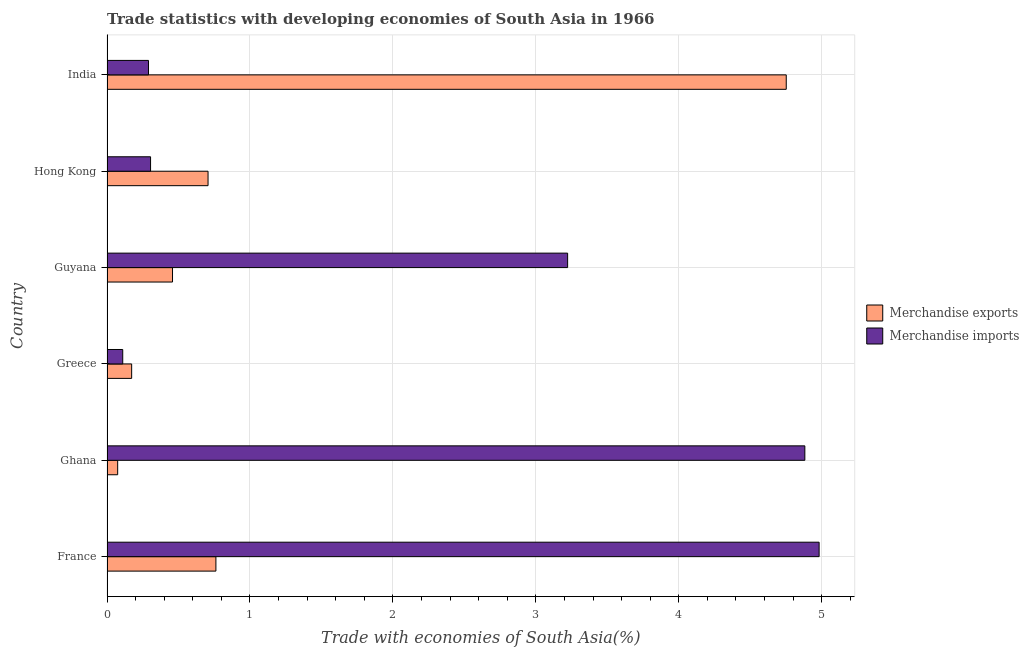Are the number of bars per tick equal to the number of legend labels?
Ensure brevity in your answer.  Yes. Are the number of bars on each tick of the Y-axis equal?
Keep it short and to the point. Yes. What is the label of the 1st group of bars from the top?
Your answer should be compact. India. What is the merchandise imports in Ghana?
Ensure brevity in your answer.  4.88. Across all countries, what is the maximum merchandise exports?
Offer a terse response. 4.75. Across all countries, what is the minimum merchandise imports?
Offer a terse response. 0.11. In which country was the merchandise imports maximum?
Offer a terse response. France. In which country was the merchandise exports minimum?
Keep it short and to the point. Ghana. What is the total merchandise exports in the graph?
Provide a short and direct response. 6.93. What is the difference between the merchandise imports in France and that in Hong Kong?
Your answer should be compact. 4.68. What is the difference between the merchandise imports in Hong Kong and the merchandise exports in Greece?
Your answer should be compact. 0.13. What is the average merchandise imports per country?
Provide a succinct answer. 2.3. What is the difference between the merchandise exports and merchandise imports in France?
Ensure brevity in your answer.  -4.22. In how many countries, is the merchandise exports greater than 4.6 %?
Keep it short and to the point. 1. What is the ratio of the merchandise exports in Guyana to that in Hong Kong?
Provide a short and direct response. 0.65. Is the merchandise imports in Guyana less than that in Hong Kong?
Your response must be concise. No. What is the difference between the highest and the second highest merchandise exports?
Ensure brevity in your answer.  3.99. What is the difference between the highest and the lowest merchandise exports?
Your answer should be very brief. 4.68. In how many countries, is the merchandise exports greater than the average merchandise exports taken over all countries?
Provide a succinct answer. 1. What does the 1st bar from the top in France represents?
Make the answer very short. Merchandise imports. What does the 1st bar from the bottom in Ghana represents?
Your answer should be very brief. Merchandise exports. How many bars are there?
Keep it short and to the point. 12. Are the values on the major ticks of X-axis written in scientific E-notation?
Provide a short and direct response. No. Does the graph contain grids?
Offer a terse response. Yes. Where does the legend appear in the graph?
Your answer should be compact. Center right. How are the legend labels stacked?
Ensure brevity in your answer.  Vertical. What is the title of the graph?
Your answer should be very brief. Trade statistics with developing economies of South Asia in 1966. What is the label or title of the X-axis?
Ensure brevity in your answer.  Trade with economies of South Asia(%). What is the Trade with economies of South Asia(%) in Merchandise exports in France?
Offer a terse response. 0.76. What is the Trade with economies of South Asia(%) of Merchandise imports in France?
Your answer should be compact. 4.98. What is the Trade with economies of South Asia(%) in Merchandise exports in Ghana?
Make the answer very short. 0.07. What is the Trade with economies of South Asia(%) of Merchandise imports in Ghana?
Offer a very short reply. 4.88. What is the Trade with economies of South Asia(%) of Merchandise exports in Greece?
Offer a terse response. 0.17. What is the Trade with economies of South Asia(%) in Merchandise imports in Greece?
Your answer should be very brief. 0.11. What is the Trade with economies of South Asia(%) of Merchandise exports in Guyana?
Offer a very short reply. 0.46. What is the Trade with economies of South Asia(%) in Merchandise imports in Guyana?
Your answer should be very brief. 3.22. What is the Trade with economies of South Asia(%) in Merchandise exports in Hong Kong?
Give a very brief answer. 0.71. What is the Trade with economies of South Asia(%) in Merchandise imports in Hong Kong?
Give a very brief answer. 0.3. What is the Trade with economies of South Asia(%) of Merchandise exports in India?
Keep it short and to the point. 4.75. What is the Trade with economies of South Asia(%) of Merchandise imports in India?
Provide a short and direct response. 0.29. Across all countries, what is the maximum Trade with economies of South Asia(%) in Merchandise exports?
Ensure brevity in your answer.  4.75. Across all countries, what is the maximum Trade with economies of South Asia(%) of Merchandise imports?
Your response must be concise. 4.98. Across all countries, what is the minimum Trade with economies of South Asia(%) of Merchandise exports?
Your answer should be very brief. 0.07. Across all countries, what is the minimum Trade with economies of South Asia(%) of Merchandise imports?
Your response must be concise. 0.11. What is the total Trade with economies of South Asia(%) of Merchandise exports in the graph?
Your answer should be very brief. 6.93. What is the total Trade with economies of South Asia(%) in Merchandise imports in the graph?
Provide a short and direct response. 13.79. What is the difference between the Trade with economies of South Asia(%) of Merchandise exports in France and that in Ghana?
Make the answer very short. 0.69. What is the difference between the Trade with economies of South Asia(%) in Merchandise imports in France and that in Ghana?
Offer a terse response. 0.1. What is the difference between the Trade with economies of South Asia(%) in Merchandise exports in France and that in Greece?
Make the answer very short. 0.59. What is the difference between the Trade with economies of South Asia(%) of Merchandise imports in France and that in Greece?
Provide a succinct answer. 4.87. What is the difference between the Trade with economies of South Asia(%) in Merchandise exports in France and that in Guyana?
Provide a succinct answer. 0.3. What is the difference between the Trade with economies of South Asia(%) of Merchandise imports in France and that in Guyana?
Offer a very short reply. 1.76. What is the difference between the Trade with economies of South Asia(%) of Merchandise exports in France and that in Hong Kong?
Provide a short and direct response. 0.06. What is the difference between the Trade with economies of South Asia(%) in Merchandise imports in France and that in Hong Kong?
Your response must be concise. 4.68. What is the difference between the Trade with economies of South Asia(%) of Merchandise exports in France and that in India?
Your answer should be very brief. -3.99. What is the difference between the Trade with economies of South Asia(%) of Merchandise imports in France and that in India?
Provide a short and direct response. 4.69. What is the difference between the Trade with economies of South Asia(%) in Merchandise exports in Ghana and that in Greece?
Make the answer very short. -0.1. What is the difference between the Trade with economies of South Asia(%) of Merchandise imports in Ghana and that in Greece?
Give a very brief answer. 4.77. What is the difference between the Trade with economies of South Asia(%) of Merchandise exports in Ghana and that in Guyana?
Keep it short and to the point. -0.38. What is the difference between the Trade with economies of South Asia(%) in Merchandise imports in Ghana and that in Guyana?
Ensure brevity in your answer.  1.66. What is the difference between the Trade with economies of South Asia(%) in Merchandise exports in Ghana and that in Hong Kong?
Your answer should be very brief. -0.63. What is the difference between the Trade with economies of South Asia(%) in Merchandise imports in Ghana and that in Hong Kong?
Offer a very short reply. 4.58. What is the difference between the Trade with economies of South Asia(%) of Merchandise exports in Ghana and that in India?
Keep it short and to the point. -4.68. What is the difference between the Trade with economies of South Asia(%) of Merchandise imports in Ghana and that in India?
Offer a very short reply. 4.59. What is the difference between the Trade with economies of South Asia(%) in Merchandise exports in Greece and that in Guyana?
Your response must be concise. -0.29. What is the difference between the Trade with economies of South Asia(%) of Merchandise imports in Greece and that in Guyana?
Your response must be concise. -3.11. What is the difference between the Trade with economies of South Asia(%) in Merchandise exports in Greece and that in Hong Kong?
Provide a succinct answer. -0.53. What is the difference between the Trade with economies of South Asia(%) of Merchandise imports in Greece and that in Hong Kong?
Ensure brevity in your answer.  -0.19. What is the difference between the Trade with economies of South Asia(%) of Merchandise exports in Greece and that in India?
Your answer should be very brief. -4.58. What is the difference between the Trade with economies of South Asia(%) of Merchandise imports in Greece and that in India?
Provide a succinct answer. -0.18. What is the difference between the Trade with economies of South Asia(%) in Merchandise exports in Guyana and that in Hong Kong?
Your response must be concise. -0.25. What is the difference between the Trade with economies of South Asia(%) in Merchandise imports in Guyana and that in Hong Kong?
Offer a very short reply. 2.92. What is the difference between the Trade with economies of South Asia(%) in Merchandise exports in Guyana and that in India?
Offer a very short reply. -4.29. What is the difference between the Trade with economies of South Asia(%) in Merchandise imports in Guyana and that in India?
Your answer should be compact. 2.93. What is the difference between the Trade with economies of South Asia(%) in Merchandise exports in Hong Kong and that in India?
Ensure brevity in your answer.  -4.04. What is the difference between the Trade with economies of South Asia(%) in Merchandise imports in Hong Kong and that in India?
Keep it short and to the point. 0.01. What is the difference between the Trade with economies of South Asia(%) of Merchandise exports in France and the Trade with economies of South Asia(%) of Merchandise imports in Ghana?
Offer a very short reply. -4.12. What is the difference between the Trade with economies of South Asia(%) in Merchandise exports in France and the Trade with economies of South Asia(%) in Merchandise imports in Greece?
Offer a very short reply. 0.65. What is the difference between the Trade with economies of South Asia(%) of Merchandise exports in France and the Trade with economies of South Asia(%) of Merchandise imports in Guyana?
Keep it short and to the point. -2.46. What is the difference between the Trade with economies of South Asia(%) of Merchandise exports in France and the Trade with economies of South Asia(%) of Merchandise imports in Hong Kong?
Offer a terse response. 0.46. What is the difference between the Trade with economies of South Asia(%) of Merchandise exports in France and the Trade with economies of South Asia(%) of Merchandise imports in India?
Provide a short and direct response. 0.47. What is the difference between the Trade with economies of South Asia(%) in Merchandise exports in Ghana and the Trade with economies of South Asia(%) in Merchandise imports in Greece?
Your answer should be very brief. -0.04. What is the difference between the Trade with economies of South Asia(%) of Merchandise exports in Ghana and the Trade with economies of South Asia(%) of Merchandise imports in Guyana?
Provide a short and direct response. -3.15. What is the difference between the Trade with economies of South Asia(%) of Merchandise exports in Ghana and the Trade with economies of South Asia(%) of Merchandise imports in Hong Kong?
Your response must be concise. -0.23. What is the difference between the Trade with economies of South Asia(%) of Merchandise exports in Ghana and the Trade with economies of South Asia(%) of Merchandise imports in India?
Ensure brevity in your answer.  -0.22. What is the difference between the Trade with economies of South Asia(%) of Merchandise exports in Greece and the Trade with economies of South Asia(%) of Merchandise imports in Guyana?
Ensure brevity in your answer.  -3.05. What is the difference between the Trade with economies of South Asia(%) of Merchandise exports in Greece and the Trade with economies of South Asia(%) of Merchandise imports in Hong Kong?
Your response must be concise. -0.13. What is the difference between the Trade with economies of South Asia(%) of Merchandise exports in Greece and the Trade with economies of South Asia(%) of Merchandise imports in India?
Offer a very short reply. -0.12. What is the difference between the Trade with economies of South Asia(%) of Merchandise exports in Guyana and the Trade with economies of South Asia(%) of Merchandise imports in Hong Kong?
Give a very brief answer. 0.15. What is the difference between the Trade with economies of South Asia(%) of Merchandise exports in Guyana and the Trade with economies of South Asia(%) of Merchandise imports in India?
Keep it short and to the point. 0.17. What is the difference between the Trade with economies of South Asia(%) in Merchandise exports in Hong Kong and the Trade with economies of South Asia(%) in Merchandise imports in India?
Offer a very short reply. 0.42. What is the average Trade with economies of South Asia(%) of Merchandise exports per country?
Give a very brief answer. 1.15. What is the average Trade with economies of South Asia(%) of Merchandise imports per country?
Provide a short and direct response. 2.3. What is the difference between the Trade with economies of South Asia(%) of Merchandise exports and Trade with economies of South Asia(%) of Merchandise imports in France?
Keep it short and to the point. -4.22. What is the difference between the Trade with economies of South Asia(%) of Merchandise exports and Trade with economies of South Asia(%) of Merchandise imports in Ghana?
Your answer should be compact. -4.81. What is the difference between the Trade with economies of South Asia(%) of Merchandise exports and Trade with economies of South Asia(%) of Merchandise imports in Greece?
Ensure brevity in your answer.  0.06. What is the difference between the Trade with economies of South Asia(%) of Merchandise exports and Trade with economies of South Asia(%) of Merchandise imports in Guyana?
Keep it short and to the point. -2.76. What is the difference between the Trade with economies of South Asia(%) in Merchandise exports and Trade with economies of South Asia(%) in Merchandise imports in Hong Kong?
Ensure brevity in your answer.  0.4. What is the difference between the Trade with economies of South Asia(%) in Merchandise exports and Trade with economies of South Asia(%) in Merchandise imports in India?
Your answer should be compact. 4.46. What is the ratio of the Trade with economies of South Asia(%) in Merchandise exports in France to that in Ghana?
Your answer should be compact. 10.21. What is the ratio of the Trade with economies of South Asia(%) in Merchandise imports in France to that in Ghana?
Your answer should be very brief. 1.02. What is the ratio of the Trade with economies of South Asia(%) of Merchandise exports in France to that in Greece?
Provide a succinct answer. 4.42. What is the ratio of the Trade with economies of South Asia(%) of Merchandise imports in France to that in Greece?
Your response must be concise. 45.28. What is the ratio of the Trade with economies of South Asia(%) in Merchandise exports in France to that in Guyana?
Provide a succinct answer. 1.66. What is the ratio of the Trade with economies of South Asia(%) of Merchandise imports in France to that in Guyana?
Provide a short and direct response. 1.55. What is the ratio of the Trade with economies of South Asia(%) in Merchandise exports in France to that in Hong Kong?
Your response must be concise. 1.08. What is the ratio of the Trade with economies of South Asia(%) in Merchandise imports in France to that in Hong Kong?
Give a very brief answer. 16.35. What is the ratio of the Trade with economies of South Asia(%) in Merchandise exports in France to that in India?
Offer a very short reply. 0.16. What is the ratio of the Trade with economies of South Asia(%) in Merchandise imports in France to that in India?
Your response must be concise. 17.17. What is the ratio of the Trade with economies of South Asia(%) of Merchandise exports in Ghana to that in Greece?
Keep it short and to the point. 0.43. What is the ratio of the Trade with economies of South Asia(%) in Merchandise imports in Ghana to that in Greece?
Your answer should be compact. 44.38. What is the ratio of the Trade with economies of South Asia(%) in Merchandise exports in Ghana to that in Guyana?
Keep it short and to the point. 0.16. What is the ratio of the Trade with economies of South Asia(%) in Merchandise imports in Ghana to that in Guyana?
Offer a terse response. 1.51. What is the ratio of the Trade with economies of South Asia(%) in Merchandise exports in Ghana to that in Hong Kong?
Your response must be concise. 0.11. What is the ratio of the Trade with economies of South Asia(%) in Merchandise imports in Ghana to that in Hong Kong?
Your answer should be compact. 16.02. What is the ratio of the Trade with economies of South Asia(%) of Merchandise exports in Ghana to that in India?
Ensure brevity in your answer.  0.02. What is the ratio of the Trade with economies of South Asia(%) in Merchandise imports in Ghana to that in India?
Provide a succinct answer. 16.83. What is the ratio of the Trade with economies of South Asia(%) of Merchandise exports in Greece to that in Guyana?
Provide a short and direct response. 0.38. What is the ratio of the Trade with economies of South Asia(%) of Merchandise imports in Greece to that in Guyana?
Give a very brief answer. 0.03. What is the ratio of the Trade with economies of South Asia(%) in Merchandise exports in Greece to that in Hong Kong?
Provide a short and direct response. 0.24. What is the ratio of the Trade with economies of South Asia(%) in Merchandise imports in Greece to that in Hong Kong?
Offer a very short reply. 0.36. What is the ratio of the Trade with economies of South Asia(%) of Merchandise exports in Greece to that in India?
Provide a succinct answer. 0.04. What is the ratio of the Trade with economies of South Asia(%) of Merchandise imports in Greece to that in India?
Ensure brevity in your answer.  0.38. What is the ratio of the Trade with economies of South Asia(%) of Merchandise exports in Guyana to that in Hong Kong?
Give a very brief answer. 0.65. What is the ratio of the Trade with economies of South Asia(%) of Merchandise imports in Guyana to that in Hong Kong?
Offer a very short reply. 10.57. What is the ratio of the Trade with economies of South Asia(%) in Merchandise exports in Guyana to that in India?
Your answer should be very brief. 0.1. What is the ratio of the Trade with economies of South Asia(%) of Merchandise imports in Guyana to that in India?
Provide a short and direct response. 11.11. What is the ratio of the Trade with economies of South Asia(%) in Merchandise exports in Hong Kong to that in India?
Your answer should be compact. 0.15. What is the ratio of the Trade with economies of South Asia(%) in Merchandise imports in Hong Kong to that in India?
Provide a short and direct response. 1.05. What is the difference between the highest and the second highest Trade with economies of South Asia(%) in Merchandise exports?
Ensure brevity in your answer.  3.99. What is the difference between the highest and the second highest Trade with economies of South Asia(%) in Merchandise imports?
Provide a succinct answer. 0.1. What is the difference between the highest and the lowest Trade with economies of South Asia(%) in Merchandise exports?
Provide a succinct answer. 4.68. What is the difference between the highest and the lowest Trade with economies of South Asia(%) of Merchandise imports?
Your response must be concise. 4.87. 